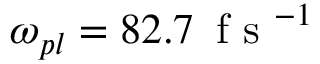<formula> <loc_0><loc_0><loc_500><loc_500>\omega _ { p l } = 8 2 . 7 \, f s ^ { - 1 }</formula> 